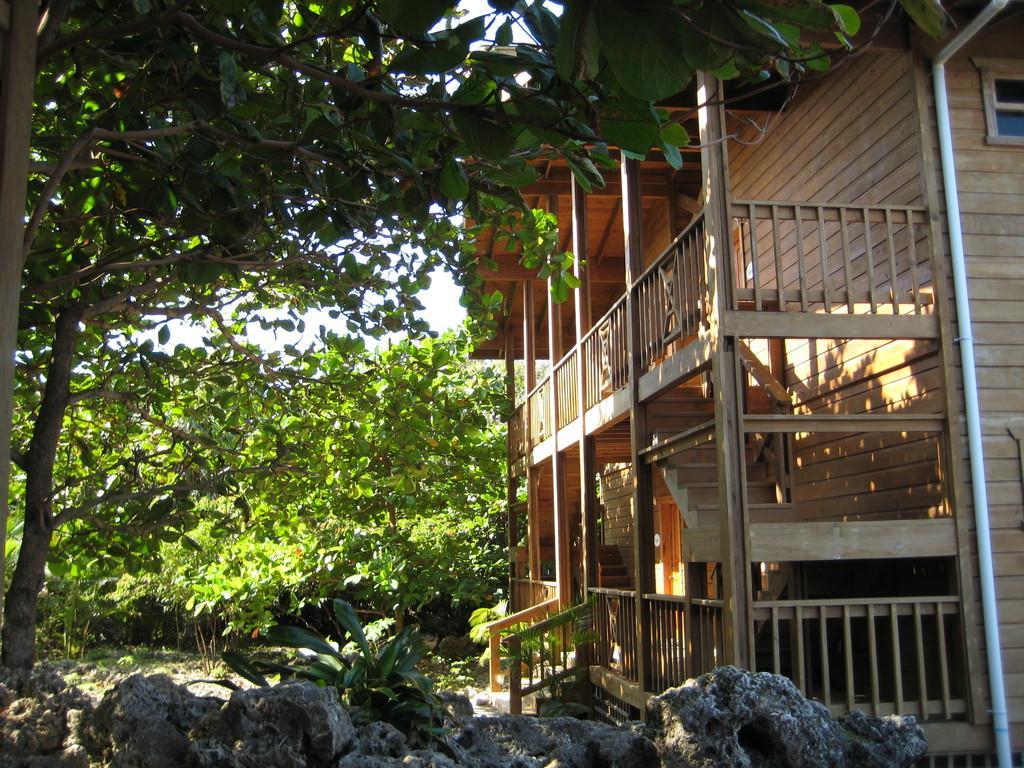Could you give a brief overview of what you see in this image? To the bottom of the image there are stones and also there is grass. To the left side of the image there are many trees. And to the right side of the image there is a wooden building with wall, balcony, steps, railing and also there is a plastic pipe and glass window. 